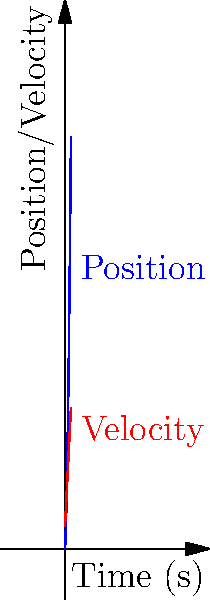During the annual Peoria Balloon Fest, a hot air balloon's position (in meters) as a function of time t (in seconds) is given by $s(t) = 10t^2 + 20t$. Find the acceleration of the balloon at t = 3 seconds. To find the acceleration of the balloon at t = 3 seconds, we need to follow these steps:

1. First, we need to find the velocity function by taking the derivative of the position function:
   $s(t) = 10t^2 + 20t$
   $v(t) = \frac{d}{dt}s(t) = 20t + 20$

2. Now, to find the acceleration function, we take the derivative of the velocity function:
   $a(t) = \frac{d}{dt}v(t) = 20$

3. We can see that the acceleration is constant at 20 m/s².

4. Since the question asks for the acceleration at t = 3 seconds, and the acceleration is constant, we don't need to substitute t = 3 into the acceleration function.

Therefore, the acceleration of the balloon at t = 3 seconds (and at any other time) is 20 m/s².
Answer: 20 m/s² 